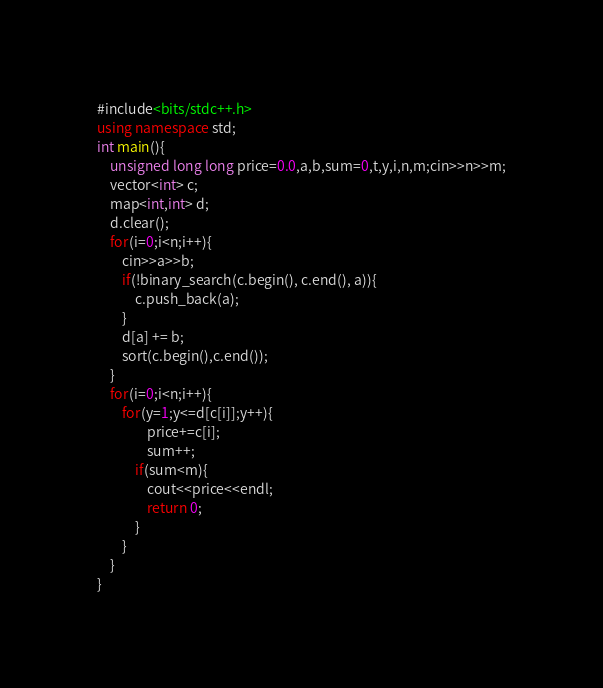<code> <loc_0><loc_0><loc_500><loc_500><_C++_>#include<bits/stdc++.h>
using namespace std;
int main(){
    unsigned long long price=0.0,a,b,sum=0,t,y,i,n,m;cin>>n>>m;
    vector<int> c;
    map<int,int> d;
    d.clear();
    for(i=0;i<n;i++){
        cin>>a>>b;
        if(!binary_search(c.begin(), c.end(), a)){
            c.push_back(a);
        }
        d[a] += b;
        sort(c.begin(),c.end());
    }
    for(i=0;i<n;i++){
        for(y=1;y<=d[c[i]];y++){
                price+=c[i];
                sum++;
            if(sum<m){
                cout<<price<<endl;
                return 0;
            }            
        }
    }
}</code> 